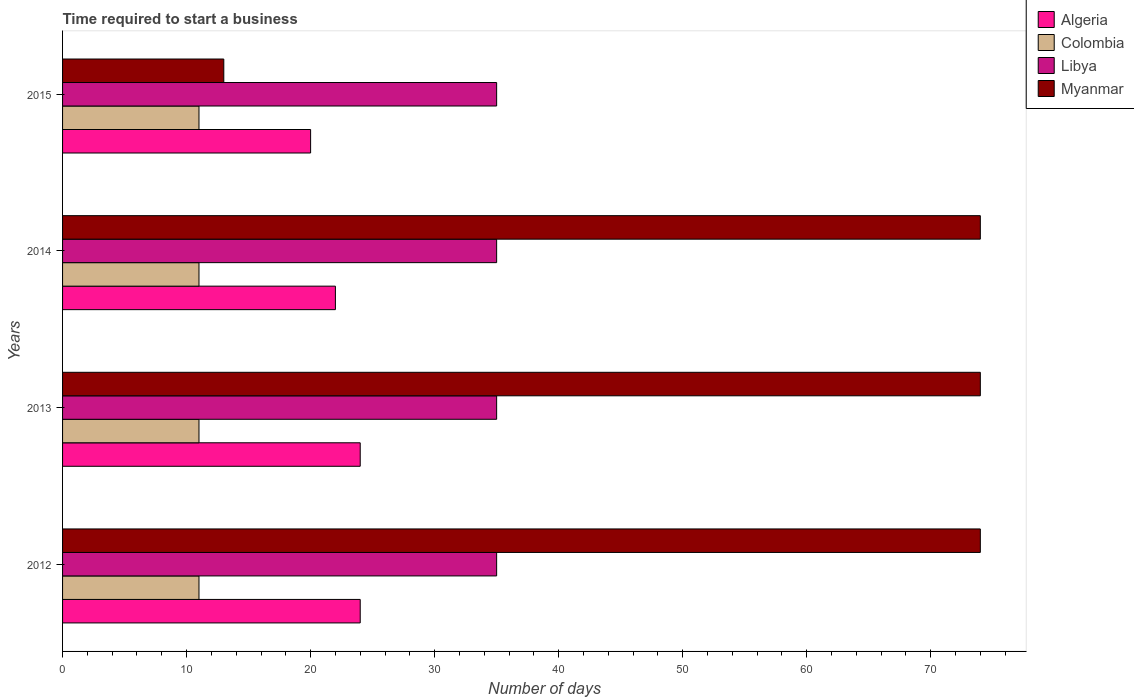How many groups of bars are there?
Offer a terse response. 4. How many bars are there on the 1st tick from the bottom?
Your answer should be very brief. 4. Across all years, what is the maximum number of days required to start a business in Libya?
Your answer should be compact. 35. Across all years, what is the minimum number of days required to start a business in Myanmar?
Make the answer very short. 13. In which year was the number of days required to start a business in Myanmar maximum?
Your answer should be compact. 2012. In which year was the number of days required to start a business in Colombia minimum?
Make the answer very short. 2012. What is the total number of days required to start a business in Algeria in the graph?
Make the answer very short. 90. In the year 2012, what is the difference between the number of days required to start a business in Colombia and number of days required to start a business in Algeria?
Make the answer very short. -13. Is the difference between the number of days required to start a business in Colombia in 2012 and 2014 greater than the difference between the number of days required to start a business in Algeria in 2012 and 2014?
Ensure brevity in your answer.  No. What is the difference between the highest and the second highest number of days required to start a business in Colombia?
Your answer should be very brief. 0. What is the difference between the highest and the lowest number of days required to start a business in Colombia?
Make the answer very short. 0. In how many years, is the number of days required to start a business in Algeria greater than the average number of days required to start a business in Algeria taken over all years?
Your response must be concise. 2. Is it the case that in every year, the sum of the number of days required to start a business in Colombia and number of days required to start a business in Algeria is greater than the sum of number of days required to start a business in Libya and number of days required to start a business in Myanmar?
Provide a short and direct response. No. What does the 4th bar from the top in 2015 represents?
Your answer should be very brief. Algeria. What does the 4th bar from the bottom in 2013 represents?
Your answer should be very brief. Myanmar. Is it the case that in every year, the sum of the number of days required to start a business in Myanmar and number of days required to start a business in Libya is greater than the number of days required to start a business in Algeria?
Keep it short and to the point. Yes. How many bars are there?
Ensure brevity in your answer.  16. Are all the bars in the graph horizontal?
Your response must be concise. Yes. What is the difference between two consecutive major ticks on the X-axis?
Your answer should be very brief. 10. Does the graph contain any zero values?
Offer a very short reply. No. Does the graph contain grids?
Make the answer very short. No. What is the title of the graph?
Provide a succinct answer. Time required to start a business. Does "Grenada" appear as one of the legend labels in the graph?
Your response must be concise. No. What is the label or title of the X-axis?
Ensure brevity in your answer.  Number of days. What is the Number of days in Libya in 2012?
Your answer should be very brief. 35. What is the Number of days of Algeria in 2013?
Your answer should be very brief. 24. What is the Number of days of Myanmar in 2013?
Offer a terse response. 74. What is the Number of days in Algeria in 2014?
Offer a very short reply. 22. What is the Number of days of Colombia in 2014?
Offer a very short reply. 11. What is the Number of days in Libya in 2014?
Make the answer very short. 35. What is the Number of days of Libya in 2015?
Offer a very short reply. 35. Across all years, what is the maximum Number of days of Myanmar?
Offer a terse response. 74. Across all years, what is the minimum Number of days of Libya?
Offer a very short reply. 35. Across all years, what is the minimum Number of days in Myanmar?
Ensure brevity in your answer.  13. What is the total Number of days in Algeria in the graph?
Provide a short and direct response. 90. What is the total Number of days of Colombia in the graph?
Give a very brief answer. 44. What is the total Number of days of Libya in the graph?
Make the answer very short. 140. What is the total Number of days in Myanmar in the graph?
Provide a succinct answer. 235. What is the difference between the Number of days of Colombia in 2012 and that in 2013?
Ensure brevity in your answer.  0. What is the difference between the Number of days of Myanmar in 2012 and that in 2013?
Your response must be concise. 0. What is the difference between the Number of days of Libya in 2012 and that in 2014?
Your answer should be very brief. 0. What is the difference between the Number of days of Myanmar in 2012 and that in 2014?
Keep it short and to the point. 0. What is the difference between the Number of days in Colombia in 2012 and that in 2015?
Keep it short and to the point. 0. What is the difference between the Number of days of Libya in 2012 and that in 2015?
Keep it short and to the point. 0. What is the difference between the Number of days in Myanmar in 2012 and that in 2015?
Provide a succinct answer. 61. What is the difference between the Number of days of Libya in 2013 and that in 2014?
Ensure brevity in your answer.  0. What is the difference between the Number of days in Algeria in 2013 and that in 2015?
Your answer should be compact. 4. What is the difference between the Number of days in Colombia in 2013 and that in 2015?
Your answer should be compact. 0. What is the difference between the Number of days of Myanmar in 2013 and that in 2015?
Give a very brief answer. 61. What is the difference between the Number of days of Algeria in 2014 and that in 2015?
Your answer should be compact. 2. What is the difference between the Number of days of Colombia in 2014 and that in 2015?
Keep it short and to the point. 0. What is the difference between the Number of days in Algeria in 2012 and the Number of days in Libya in 2013?
Your response must be concise. -11. What is the difference between the Number of days of Colombia in 2012 and the Number of days of Myanmar in 2013?
Your response must be concise. -63. What is the difference between the Number of days of Libya in 2012 and the Number of days of Myanmar in 2013?
Give a very brief answer. -39. What is the difference between the Number of days in Algeria in 2012 and the Number of days in Myanmar in 2014?
Offer a very short reply. -50. What is the difference between the Number of days in Colombia in 2012 and the Number of days in Libya in 2014?
Provide a short and direct response. -24. What is the difference between the Number of days of Colombia in 2012 and the Number of days of Myanmar in 2014?
Your answer should be compact. -63. What is the difference between the Number of days of Libya in 2012 and the Number of days of Myanmar in 2014?
Ensure brevity in your answer.  -39. What is the difference between the Number of days in Algeria in 2012 and the Number of days in Libya in 2015?
Give a very brief answer. -11. What is the difference between the Number of days of Libya in 2012 and the Number of days of Myanmar in 2015?
Your answer should be very brief. 22. What is the difference between the Number of days of Algeria in 2013 and the Number of days of Colombia in 2014?
Offer a terse response. 13. What is the difference between the Number of days of Algeria in 2013 and the Number of days of Libya in 2014?
Give a very brief answer. -11. What is the difference between the Number of days of Colombia in 2013 and the Number of days of Libya in 2014?
Ensure brevity in your answer.  -24. What is the difference between the Number of days in Colombia in 2013 and the Number of days in Myanmar in 2014?
Make the answer very short. -63. What is the difference between the Number of days in Libya in 2013 and the Number of days in Myanmar in 2014?
Make the answer very short. -39. What is the difference between the Number of days of Algeria in 2013 and the Number of days of Libya in 2015?
Ensure brevity in your answer.  -11. What is the difference between the Number of days in Algeria in 2013 and the Number of days in Myanmar in 2015?
Your answer should be compact. 11. What is the difference between the Number of days in Colombia in 2013 and the Number of days in Libya in 2015?
Ensure brevity in your answer.  -24. What is the difference between the Number of days in Libya in 2013 and the Number of days in Myanmar in 2015?
Keep it short and to the point. 22. What is the difference between the Number of days of Algeria in 2014 and the Number of days of Colombia in 2015?
Offer a terse response. 11. What is the difference between the Number of days of Algeria in 2014 and the Number of days of Myanmar in 2015?
Provide a short and direct response. 9. What is the difference between the Number of days in Colombia in 2014 and the Number of days in Myanmar in 2015?
Give a very brief answer. -2. What is the difference between the Number of days in Libya in 2014 and the Number of days in Myanmar in 2015?
Your response must be concise. 22. What is the average Number of days in Colombia per year?
Offer a very short reply. 11. What is the average Number of days of Libya per year?
Offer a very short reply. 35. What is the average Number of days in Myanmar per year?
Provide a short and direct response. 58.75. In the year 2012, what is the difference between the Number of days in Colombia and Number of days in Myanmar?
Ensure brevity in your answer.  -63. In the year 2012, what is the difference between the Number of days in Libya and Number of days in Myanmar?
Ensure brevity in your answer.  -39. In the year 2013, what is the difference between the Number of days in Algeria and Number of days in Libya?
Provide a succinct answer. -11. In the year 2013, what is the difference between the Number of days of Colombia and Number of days of Libya?
Offer a terse response. -24. In the year 2013, what is the difference between the Number of days in Colombia and Number of days in Myanmar?
Your answer should be very brief. -63. In the year 2013, what is the difference between the Number of days of Libya and Number of days of Myanmar?
Your response must be concise. -39. In the year 2014, what is the difference between the Number of days of Algeria and Number of days of Colombia?
Provide a short and direct response. 11. In the year 2014, what is the difference between the Number of days in Algeria and Number of days in Myanmar?
Provide a succinct answer. -52. In the year 2014, what is the difference between the Number of days in Colombia and Number of days in Libya?
Make the answer very short. -24. In the year 2014, what is the difference between the Number of days in Colombia and Number of days in Myanmar?
Give a very brief answer. -63. In the year 2014, what is the difference between the Number of days of Libya and Number of days of Myanmar?
Your answer should be very brief. -39. In the year 2015, what is the difference between the Number of days in Algeria and Number of days in Myanmar?
Keep it short and to the point. 7. In the year 2015, what is the difference between the Number of days in Colombia and Number of days in Libya?
Your answer should be very brief. -24. In the year 2015, what is the difference between the Number of days of Libya and Number of days of Myanmar?
Your answer should be very brief. 22. What is the ratio of the Number of days of Colombia in 2012 to that in 2014?
Offer a terse response. 1. What is the ratio of the Number of days of Myanmar in 2012 to that in 2014?
Provide a short and direct response. 1. What is the ratio of the Number of days in Myanmar in 2012 to that in 2015?
Give a very brief answer. 5.69. What is the ratio of the Number of days in Algeria in 2013 to that in 2014?
Offer a terse response. 1.09. What is the ratio of the Number of days in Colombia in 2013 to that in 2014?
Your answer should be very brief. 1. What is the ratio of the Number of days in Libya in 2013 to that in 2014?
Offer a very short reply. 1. What is the ratio of the Number of days of Myanmar in 2013 to that in 2014?
Your response must be concise. 1. What is the ratio of the Number of days of Colombia in 2013 to that in 2015?
Provide a succinct answer. 1. What is the ratio of the Number of days in Myanmar in 2013 to that in 2015?
Make the answer very short. 5.69. What is the ratio of the Number of days of Algeria in 2014 to that in 2015?
Provide a short and direct response. 1.1. What is the ratio of the Number of days of Colombia in 2014 to that in 2015?
Your answer should be compact. 1. What is the ratio of the Number of days of Myanmar in 2014 to that in 2015?
Your answer should be compact. 5.69. What is the difference between the highest and the second highest Number of days of Libya?
Your answer should be compact. 0. What is the difference between the highest and the lowest Number of days in Algeria?
Ensure brevity in your answer.  4. What is the difference between the highest and the lowest Number of days in Libya?
Keep it short and to the point. 0. 